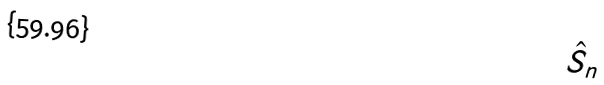Convert formula to latex. <formula><loc_0><loc_0><loc_500><loc_500>\hat { S } _ { n }</formula> 